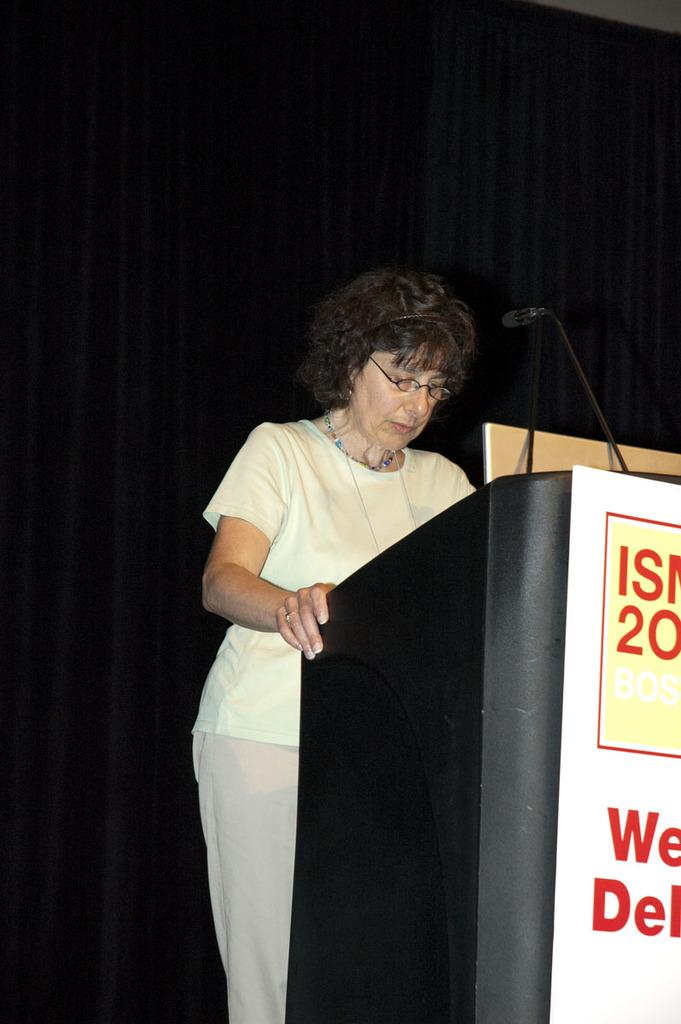Who is the main subject in the image? There is a woman in the image. What is the woman doing in the image? The woman is standing near a podium. What object is attached to the podium? A microphone is attached to the podium. What can be seen in the background of the image? There is a curtain in the background of the image. What type of rail is visible in the image? There is no rail present in the image. Is the woman wearing a crown in the image? The woman is not wearing a crown in the image. 